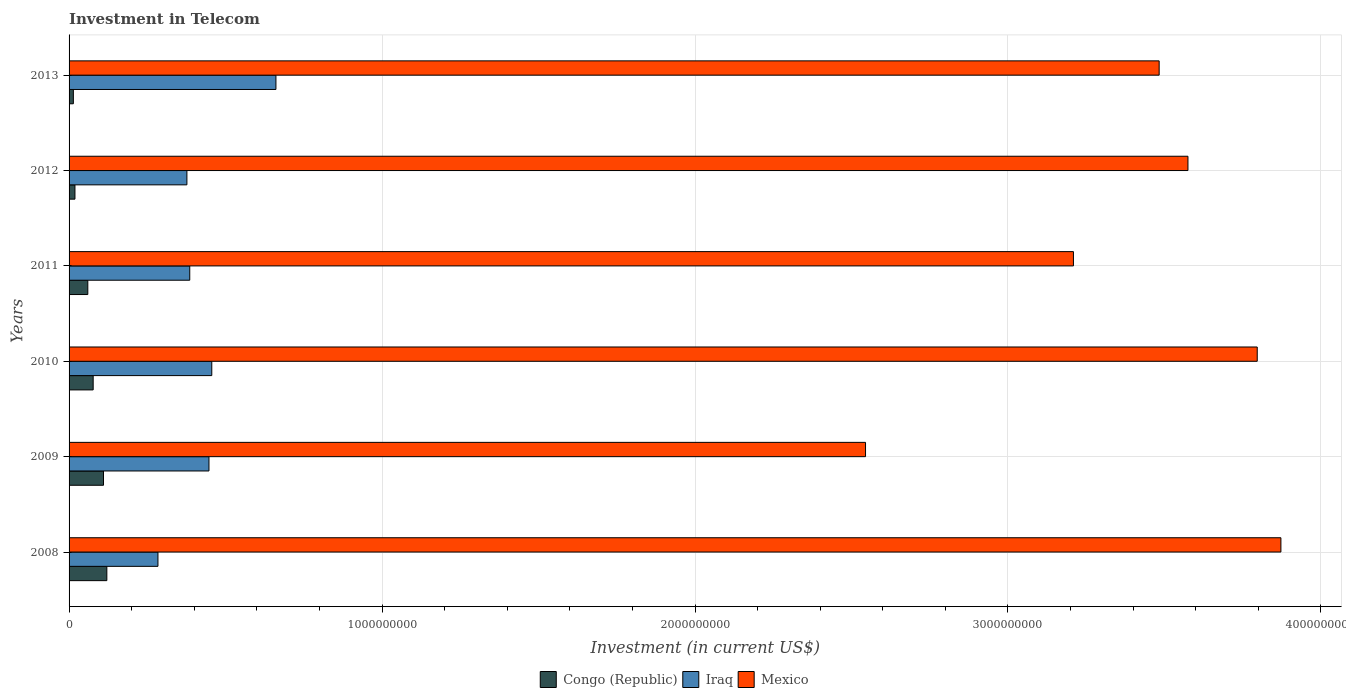How many different coloured bars are there?
Your answer should be compact. 3. How many groups of bars are there?
Make the answer very short. 6. Are the number of bars on each tick of the Y-axis equal?
Offer a terse response. Yes. How many bars are there on the 6th tick from the top?
Make the answer very short. 3. How many bars are there on the 6th tick from the bottom?
Your response must be concise. 3. What is the label of the 5th group of bars from the top?
Provide a succinct answer. 2009. In how many cases, is the number of bars for a given year not equal to the number of legend labels?
Give a very brief answer. 0. What is the amount invested in telecom in Congo (Republic) in 2010?
Provide a short and direct response. 7.70e+07. Across all years, what is the maximum amount invested in telecom in Iraq?
Provide a short and direct response. 6.61e+08. Across all years, what is the minimum amount invested in telecom in Mexico?
Provide a succinct answer. 2.54e+09. In which year was the amount invested in telecom in Mexico maximum?
Provide a succinct answer. 2008. In which year was the amount invested in telecom in Iraq minimum?
Provide a short and direct response. 2008. What is the total amount invested in telecom in Iraq in the graph?
Your answer should be compact. 2.61e+09. What is the difference between the amount invested in telecom in Mexico in 2008 and that in 2010?
Make the answer very short. 7.56e+07. What is the difference between the amount invested in telecom in Mexico in 2011 and the amount invested in telecom in Iraq in 2012?
Make the answer very short. 2.83e+09. What is the average amount invested in telecom in Mexico per year?
Your response must be concise. 3.41e+09. In the year 2012, what is the difference between the amount invested in telecom in Mexico and amount invested in telecom in Congo (Republic)?
Offer a terse response. 3.56e+09. What is the ratio of the amount invested in telecom in Iraq in 2008 to that in 2010?
Provide a short and direct response. 0.62. Is the difference between the amount invested in telecom in Mexico in 2011 and 2013 greater than the difference between the amount invested in telecom in Congo (Republic) in 2011 and 2013?
Provide a short and direct response. No. What is the difference between the highest and the second highest amount invested in telecom in Congo (Republic)?
Provide a succinct answer. 1.07e+07. What is the difference between the highest and the lowest amount invested in telecom in Iraq?
Your answer should be compact. 3.77e+08. In how many years, is the amount invested in telecom in Iraq greater than the average amount invested in telecom in Iraq taken over all years?
Your answer should be very brief. 3. Is the sum of the amount invested in telecom in Iraq in 2011 and 2013 greater than the maximum amount invested in telecom in Mexico across all years?
Offer a very short reply. No. What does the 1st bar from the top in 2010 represents?
Provide a short and direct response. Mexico. What does the 3rd bar from the bottom in 2009 represents?
Keep it short and to the point. Mexico. Is it the case that in every year, the sum of the amount invested in telecom in Mexico and amount invested in telecom in Iraq is greater than the amount invested in telecom in Congo (Republic)?
Make the answer very short. Yes. How many bars are there?
Your answer should be compact. 18. What is the difference between two consecutive major ticks on the X-axis?
Ensure brevity in your answer.  1.00e+09. Does the graph contain any zero values?
Your answer should be compact. No. Where does the legend appear in the graph?
Your response must be concise. Bottom center. How are the legend labels stacked?
Offer a terse response. Horizontal. What is the title of the graph?
Make the answer very short. Investment in Telecom. What is the label or title of the X-axis?
Offer a very short reply. Investment (in current US$). What is the Investment (in current US$) of Congo (Republic) in 2008?
Ensure brevity in your answer.  1.21e+08. What is the Investment (in current US$) of Iraq in 2008?
Provide a succinct answer. 2.84e+08. What is the Investment (in current US$) of Mexico in 2008?
Provide a succinct answer. 3.87e+09. What is the Investment (in current US$) of Congo (Republic) in 2009?
Ensure brevity in your answer.  1.10e+08. What is the Investment (in current US$) of Iraq in 2009?
Your answer should be very brief. 4.47e+08. What is the Investment (in current US$) in Mexico in 2009?
Provide a short and direct response. 2.54e+09. What is the Investment (in current US$) of Congo (Republic) in 2010?
Offer a terse response. 7.70e+07. What is the Investment (in current US$) of Iraq in 2010?
Ensure brevity in your answer.  4.56e+08. What is the Investment (in current US$) in Mexico in 2010?
Provide a succinct answer. 3.80e+09. What is the Investment (in current US$) of Congo (Republic) in 2011?
Your answer should be very brief. 5.99e+07. What is the Investment (in current US$) in Iraq in 2011?
Make the answer very short. 3.86e+08. What is the Investment (in current US$) in Mexico in 2011?
Offer a terse response. 3.21e+09. What is the Investment (in current US$) of Congo (Republic) in 2012?
Keep it short and to the point. 1.88e+07. What is the Investment (in current US$) of Iraq in 2012?
Provide a short and direct response. 3.76e+08. What is the Investment (in current US$) in Mexico in 2012?
Your answer should be very brief. 3.58e+09. What is the Investment (in current US$) of Congo (Republic) in 2013?
Provide a short and direct response. 1.37e+07. What is the Investment (in current US$) in Iraq in 2013?
Offer a terse response. 6.61e+08. What is the Investment (in current US$) in Mexico in 2013?
Give a very brief answer. 3.48e+09. Across all years, what is the maximum Investment (in current US$) of Congo (Republic)?
Ensure brevity in your answer.  1.21e+08. Across all years, what is the maximum Investment (in current US$) in Iraq?
Your answer should be very brief. 6.61e+08. Across all years, what is the maximum Investment (in current US$) of Mexico?
Provide a succinct answer. 3.87e+09. Across all years, what is the minimum Investment (in current US$) of Congo (Republic)?
Provide a succinct answer. 1.37e+07. Across all years, what is the minimum Investment (in current US$) in Iraq?
Your answer should be very brief. 2.84e+08. Across all years, what is the minimum Investment (in current US$) of Mexico?
Ensure brevity in your answer.  2.54e+09. What is the total Investment (in current US$) in Congo (Republic) in the graph?
Keep it short and to the point. 4.00e+08. What is the total Investment (in current US$) in Iraq in the graph?
Your answer should be very brief. 2.61e+09. What is the total Investment (in current US$) of Mexico in the graph?
Your answer should be very brief. 2.05e+1. What is the difference between the Investment (in current US$) in Congo (Republic) in 2008 and that in 2009?
Your response must be concise. 1.07e+07. What is the difference between the Investment (in current US$) in Iraq in 2008 and that in 2009?
Ensure brevity in your answer.  -1.63e+08. What is the difference between the Investment (in current US$) of Mexico in 2008 and that in 2009?
Offer a very short reply. 1.33e+09. What is the difference between the Investment (in current US$) in Congo (Republic) in 2008 and that in 2010?
Offer a very short reply. 4.37e+07. What is the difference between the Investment (in current US$) in Iraq in 2008 and that in 2010?
Offer a terse response. -1.72e+08. What is the difference between the Investment (in current US$) in Mexico in 2008 and that in 2010?
Keep it short and to the point. 7.56e+07. What is the difference between the Investment (in current US$) of Congo (Republic) in 2008 and that in 2011?
Provide a succinct answer. 6.08e+07. What is the difference between the Investment (in current US$) in Iraq in 2008 and that in 2011?
Provide a short and direct response. -1.02e+08. What is the difference between the Investment (in current US$) in Mexico in 2008 and that in 2011?
Ensure brevity in your answer.  6.63e+08. What is the difference between the Investment (in current US$) in Congo (Republic) in 2008 and that in 2012?
Offer a terse response. 1.02e+08. What is the difference between the Investment (in current US$) in Iraq in 2008 and that in 2012?
Keep it short and to the point. -9.25e+07. What is the difference between the Investment (in current US$) in Mexico in 2008 and that in 2012?
Your response must be concise. 2.97e+08. What is the difference between the Investment (in current US$) of Congo (Republic) in 2008 and that in 2013?
Provide a short and direct response. 1.07e+08. What is the difference between the Investment (in current US$) in Iraq in 2008 and that in 2013?
Keep it short and to the point. -3.77e+08. What is the difference between the Investment (in current US$) in Mexico in 2008 and that in 2013?
Offer a terse response. 3.89e+08. What is the difference between the Investment (in current US$) of Congo (Republic) in 2009 and that in 2010?
Ensure brevity in your answer.  3.30e+07. What is the difference between the Investment (in current US$) in Iraq in 2009 and that in 2010?
Offer a terse response. -9.00e+06. What is the difference between the Investment (in current US$) of Mexico in 2009 and that in 2010?
Ensure brevity in your answer.  -1.25e+09. What is the difference between the Investment (in current US$) in Congo (Republic) in 2009 and that in 2011?
Your answer should be compact. 5.01e+07. What is the difference between the Investment (in current US$) in Iraq in 2009 and that in 2011?
Offer a very short reply. 6.14e+07. What is the difference between the Investment (in current US$) in Mexico in 2009 and that in 2011?
Your response must be concise. -6.64e+08. What is the difference between the Investment (in current US$) in Congo (Republic) in 2009 and that in 2012?
Make the answer very short. 9.12e+07. What is the difference between the Investment (in current US$) of Iraq in 2009 and that in 2012?
Your response must be concise. 7.05e+07. What is the difference between the Investment (in current US$) of Mexico in 2009 and that in 2012?
Give a very brief answer. -1.03e+09. What is the difference between the Investment (in current US$) in Congo (Republic) in 2009 and that in 2013?
Give a very brief answer. 9.63e+07. What is the difference between the Investment (in current US$) in Iraq in 2009 and that in 2013?
Give a very brief answer. -2.14e+08. What is the difference between the Investment (in current US$) of Mexico in 2009 and that in 2013?
Your answer should be very brief. -9.38e+08. What is the difference between the Investment (in current US$) in Congo (Republic) in 2010 and that in 2011?
Keep it short and to the point. 1.71e+07. What is the difference between the Investment (in current US$) in Iraq in 2010 and that in 2011?
Your answer should be very brief. 7.04e+07. What is the difference between the Investment (in current US$) of Mexico in 2010 and that in 2011?
Make the answer very short. 5.87e+08. What is the difference between the Investment (in current US$) of Congo (Republic) in 2010 and that in 2012?
Offer a terse response. 5.82e+07. What is the difference between the Investment (in current US$) of Iraq in 2010 and that in 2012?
Your answer should be very brief. 7.95e+07. What is the difference between the Investment (in current US$) of Mexico in 2010 and that in 2012?
Ensure brevity in your answer.  2.21e+08. What is the difference between the Investment (in current US$) of Congo (Republic) in 2010 and that in 2013?
Offer a very short reply. 6.33e+07. What is the difference between the Investment (in current US$) of Iraq in 2010 and that in 2013?
Ensure brevity in your answer.  -2.05e+08. What is the difference between the Investment (in current US$) of Mexico in 2010 and that in 2013?
Give a very brief answer. 3.13e+08. What is the difference between the Investment (in current US$) in Congo (Republic) in 2011 and that in 2012?
Give a very brief answer. 4.11e+07. What is the difference between the Investment (in current US$) of Iraq in 2011 and that in 2012?
Keep it short and to the point. 9.10e+06. What is the difference between the Investment (in current US$) of Mexico in 2011 and that in 2012?
Your answer should be very brief. -3.66e+08. What is the difference between the Investment (in current US$) in Congo (Republic) in 2011 and that in 2013?
Make the answer very short. 4.62e+07. What is the difference between the Investment (in current US$) in Iraq in 2011 and that in 2013?
Your answer should be compact. -2.75e+08. What is the difference between the Investment (in current US$) of Mexico in 2011 and that in 2013?
Your answer should be very brief. -2.74e+08. What is the difference between the Investment (in current US$) in Congo (Republic) in 2012 and that in 2013?
Ensure brevity in your answer.  5.10e+06. What is the difference between the Investment (in current US$) of Iraq in 2012 and that in 2013?
Keep it short and to the point. -2.84e+08. What is the difference between the Investment (in current US$) of Mexico in 2012 and that in 2013?
Your answer should be very brief. 9.20e+07. What is the difference between the Investment (in current US$) in Congo (Republic) in 2008 and the Investment (in current US$) in Iraq in 2009?
Your answer should be compact. -3.26e+08. What is the difference between the Investment (in current US$) in Congo (Republic) in 2008 and the Investment (in current US$) in Mexico in 2009?
Provide a short and direct response. -2.42e+09. What is the difference between the Investment (in current US$) in Iraq in 2008 and the Investment (in current US$) in Mexico in 2009?
Your answer should be very brief. -2.26e+09. What is the difference between the Investment (in current US$) of Congo (Republic) in 2008 and the Investment (in current US$) of Iraq in 2010?
Your answer should be very brief. -3.35e+08. What is the difference between the Investment (in current US$) in Congo (Republic) in 2008 and the Investment (in current US$) in Mexico in 2010?
Offer a terse response. -3.68e+09. What is the difference between the Investment (in current US$) of Iraq in 2008 and the Investment (in current US$) of Mexico in 2010?
Your answer should be compact. -3.51e+09. What is the difference between the Investment (in current US$) of Congo (Republic) in 2008 and the Investment (in current US$) of Iraq in 2011?
Keep it short and to the point. -2.65e+08. What is the difference between the Investment (in current US$) in Congo (Republic) in 2008 and the Investment (in current US$) in Mexico in 2011?
Provide a short and direct response. -3.09e+09. What is the difference between the Investment (in current US$) in Iraq in 2008 and the Investment (in current US$) in Mexico in 2011?
Your response must be concise. -2.93e+09. What is the difference between the Investment (in current US$) in Congo (Republic) in 2008 and the Investment (in current US$) in Iraq in 2012?
Provide a succinct answer. -2.56e+08. What is the difference between the Investment (in current US$) in Congo (Republic) in 2008 and the Investment (in current US$) in Mexico in 2012?
Ensure brevity in your answer.  -3.45e+09. What is the difference between the Investment (in current US$) of Iraq in 2008 and the Investment (in current US$) of Mexico in 2012?
Your answer should be compact. -3.29e+09. What is the difference between the Investment (in current US$) in Congo (Republic) in 2008 and the Investment (in current US$) in Iraq in 2013?
Provide a succinct answer. -5.40e+08. What is the difference between the Investment (in current US$) in Congo (Republic) in 2008 and the Investment (in current US$) in Mexico in 2013?
Your answer should be very brief. -3.36e+09. What is the difference between the Investment (in current US$) in Iraq in 2008 and the Investment (in current US$) in Mexico in 2013?
Offer a terse response. -3.20e+09. What is the difference between the Investment (in current US$) in Congo (Republic) in 2009 and the Investment (in current US$) in Iraq in 2010?
Give a very brief answer. -3.46e+08. What is the difference between the Investment (in current US$) in Congo (Republic) in 2009 and the Investment (in current US$) in Mexico in 2010?
Offer a terse response. -3.69e+09. What is the difference between the Investment (in current US$) in Iraq in 2009 and the Investment (in current US$) in Mexico in 2010?
Your answer should be compact. -3.35e+09. What is the difference between the Investment (in current US$) of Congo (Republic) in 2009 and the Investment (in current US$) of Iraq in 2011?
Your answer should be very brief. -2.76e+08. What is the difference between the Investment (in current US$) of Congo (Republic) in 2009 and the Investment (in current US$) of Mexico in 2011?
Your answer should be compact. -3.10e+09. What is the difference between the Investment (in current US$) of Iraq in 2009 and the Investment (in current US$) of Mexico in 2011?
Give a very brief answer. -2.76e+09. What is the difference between the Investment (in current US$) in Congo (Republic) in 2009 and the Investment (in current US$) in Iraq in 2012?
Offer a terse response. -2.66e+08. What is the difference between the Investment (in current US$) of Congo (Republic) in 2009 and the Investment (in current US$) of Mexico in 2012?
Your answer should be compact. -3.47e+09. What is the difference between the Investment (in current US$) in Iraq in 2009 and the Investment (in current US$) in Mexico in 2012?
Offer a very short reply. -3.13e+09. What is the difference between the Investment (in current US$) in Congo (Republic) in 2009 and the Investment (in current US$) in Iraq in 2013?
Your answer should be compact. -5.51e+08. What is the difference between the Investment (in current US$) in Congo (Republic) in 2009 and the Investment (in current US$) in Mexico in 2013?
Ensure brevity in your answer.  -3.37e+09. What is the difference between the Investment (in current US$) in Iraq in 2009 and the Investment (in current US$) in Mexico in 2013?
Your answer should be compact. -3.04e+09. What is the difference between the Investment (in current US$) in Congo (Republic) in 2010 and the Investment (in current US$) in Iraq in 2011?
Offer a terse response. -3.09e+08. What is the difference between the Investment (in current US$) of Congo (Republic) in 2010 and the Investment (in current US$) of Mexico in 2011?
Your answer should be very brief. -3.13e+09. What is the difference between the Investment (in current US$) in Iraq in 2010 and the Investment (in current US$) in Mexico in 2011?
Provide a succinct answer. -2.75e+09. What is the difference between the Investment (in current US$) in Congo (Republic) in 2010 and the Investment (in current US$) in Iraq in 2012?
Give a very brief answer. -3.00e+08. What is the difference between the Investment (in current US$) of Congo (Republic) in 2010 and the Investment (in current US$) of Mexico in 2012?
Keep it short and to the point. -3.50e+09. What is the difference between the Investment (in current US$) of Iraq in 2010 and the Investment (in current US$) of Mexico in 2012?
Give a very brief answer. -3.12e+09. What is the difference between the Investment (in current US$) in Congo (Republic) in 2010 and the Investment (in current US$) in Iraq in 2013?
Offer a very short reply. -5.84e+08. What is the difference between the Investment (in current US$) in Congo (Republic) in 2010 and the Investment (in current US$) in Mexico in 2013?
Offer a terse response. -3.41e+09. What is the difference between the Investment (in current US$) of Iraq in 2010 and the Investment (in current US$) of Mexico in 2013?
Keep it short and to the point. -3.03e+09. What is the difference between the Investment (in current US$) in Congo (Republic) in 2011 and the Investment (in current US$) in Iraq in 2012?
Your response must be concise. -3.17e+08. What is the difference between the Investment (in current US$) of Congo (Republic) in 2011 and the Investment (in current US$) of Mexico in 2012?
Your answer should be very brief. -3.52e+09. What is the difference between the Investment (in current US$) of Iraq in 2011 and the Investment (in current US$) of Mexico in 2012?
Your response must be concise. -3.19e+09. What is the difference between the Investment (in current US$) of Congo (Republic) in 2011 and the Investment (in current US$) of Iraq in 2013?
Your answer should be compact. -6.01e+08. What is the difference between the Investment (in current US$) in Congo (Republic) in 2011 and the Investment (in current US$) in Mexico in 2013?
Offer a very short reply. -3.42e+09. What is the difference between the Investment (in current US$) of Iraq in 2011 and the Investment (in current US$) of Mexico in 2013?
Give a very brief answer. -3.10e+09. What is the difference between the Investment (in current US$) in Congo (Republic) in 2012 and the Investment (in current US$) in Iraq in 2013?
Keep it short and to the point. -6.42e+08. What is the difference between the Investment (in current US$) in Congo (Republic) in 2012 and the Investment (in current US$) in Mexico in 2013?
Your answer should be very brief. -3.46e+09. What is the difference between the Investment (in current US$) in Iraq in 2012 and the Investment (in current US$) in Mexico in 2013?
Make the answer very short. -3.11e+09. What is the average Investment (in current US$) in Congo (Republic) per year?
Give a very brief answer. 6.67e+07. What is the average Investment (in current US$) in Iraq per year?
Ensure brevity in your answer.  4.35e+08. What is the average Investment (in current US$) of Mexico per year?
Offer a very short reply. 3.41e+09. In the year 2008, what is the difference between the Investment (in current US$) of Congo (Republic) and Investment (in current US$) of Iraq?
Make the answer very short. -1.63e+08. In the year 2008, what is the difference between the Investment (in current US$) of Congo (Republic) and Investment (in current US$) of Mexico?
Keep it short and to the point. -3.75e+09. In the year 2008, what is the difference between the Investment (in current US$) of Iraq and Investment (in current US$) of Mexico?
Ensure brevity in your answer.  -3.59e+09. In the year 2009, what is the difference between the Investment (in current US$) of Congo (Republic) and Investment (in current US$) of Iraq?
Give a very brief answer. -3.37e+08. In the year 2009, what is the difference between the Investment (in current US$) of Congo (Republic) and Investment (in current US$) of Mexico?
Your response must be concise. -2.43e+09. In the year 2009, what is the difference between the Investment (in current US$) of Iraq and Investment (in current US$) of Mexico?
Offer a terse response. -2.10e+09. In the year 2010, what is the difference between the Investment (in current US$) in Congo (Republic) and Investment (in current US$) in Iraq?
Your response must be concise. -3.79e+08. In the year 2010, what is the difference between the Investment (in current US$) of Congo (Republic) and Investment (in current US$) of Mexico?
Your response must be concise. -3.72e+09. In the year 2010, what is the difference between the Investment (in current US$) of Iraq and Investment (in current US$) of Mexico?
Your response must be concise. -3.34e+09. In the year 2011, what is the difference between the Investment (in current US$) in Congo (Republic) and Investment (in current US$) in Iraq?
Provide a short and direct response. -3.26e+08. In the year 2011, what is the difference between the Investment (in current US$) of Congo (Republic) and Investment (in current US$) of Mexico?
Your response must be concise. -3.15e+09. In the year 2011, what is the difference between the Investment (in current US$) in Iraq and Investment (in current US$) in Mexico?
Your answer should be very brief. -2.82e+09. In the year 2012, what is the difference between the Investment (in current US$) of Congo (Republic) and Investment (in current US$) of Iraq?
Offer a very short reply. -3.58e+08. In the year 2012, what is the difference between the Investment (in current US$) of Congo (Republic) and Investment (in current US$) of Mexico?
Offer a terse response. -3.56e+09. In the year 2012, what is the difference between the Investment (in current US$) in Iraq and Investment (in current US$) in Mexico?
Offer a very short reply. -3.20e+09. In the year 2013, what is the difference between the Investment (in current US$) in Congo (Republic) and Investment (in current US$) in Iraq?
Offer a very short reply. -6.47e+08. In the year 2013, what is the difference between the Investment (in current US$) of Congo (Republic) and Investment (in current US$) of Mexico?
Your answer should be very brief. -3.47e+09. In the year 2013, what is the difference between the Investment (in current US$) in Iraq and Investment (in current US$) in Mexico?
Provide a short and direct response. -2.82e+09. What is the ratio of the Investment (in current US$) of Congo (Republic) in 2008 to that in 2009?
Give a very brief answer. 1.1. What is the ratio of the Investment (in current US$) in Iraq in 2008 to that in 2009?
Ensure brevity in your answer.  0.64. What is the ratio of the Investment (in current US$) of Mexico in 2008 to that in 2009?
Offer a terse response. 1.52. What is the ratio of the Investment (in current US$) in Congo (Republic) in 2008 to that in 2010?
Ensure brevity in your answer.  1.57. What is the ratio of the Investment (in current US$) in Iraq in 2008 to that in 2010?
Your answer should be compact. 0.62. What is the ratio of the Investment (in current US$) of Mexico in 2008 to that in 2010?
Give a very brief answer. 1.02. What is the ratio of the Investment (in current US$) in Congo (Republic) in 2008 to that in 2011?
Provide a short and direct response. 2.02. What is the ratio of the Investment (in current US$) of Iraq in 2008 to that in 2011?
Your answer should be very brief. 0.74. What is the ratio of the Investment (in current US$) of Mexico in 2008 to that in 2011?
Your response must be concise. 1.21. What is the ratio of the Investment (in current US$) of Congo (Republic) in 2008 to that in 2012?
Provide a succinct answer. 6.42. What is the ratio of the Investment (in current US$) of Iraq in 2008 to that in 2012?
Provide a succinct answer. 0.75. What is the ratio of the Investment (in current US$) of Mexico in 2008 to that in 2012?
Ensure brevity in your answer.  1.08. What is the ratio of the Investment (in current US$) in Congo (Republic) in 2008 to that in 2013?
Keep it short and to the point. 8.81. What is the ratio of the Investment (in current US$) in Iraq in 2008 to that in 2013?
Offer a very short reply. 0.43. What is the ratio of the Investment (in current US$) of Mexico in 2008 to that in 2013?
Give a very brief answer. 1.11. What is the ratio of the Investment (in current US$) in Congo (Republic) in 2009 to that in 2010?
Ensure brevity in your answer.  1.43. What is the ratio of the Investment (in current US$) in Iraq in 2009 to that in 2010?
Your response must be concise. 0.98. What is the ratio of the Investment (in current US$) of Mexico in 2009 to that in 2010?
Offer a very short reply. 0.67. What is the ratio of the Investment (in current US$) of Congo (Republic) in 2009 to that in 2011?
Offer a terse response. 1.84. What is the ratio of the Investment (in current US$) of Iraq in 2009 to that in 2011?
Give a very brief answer. 1.16. What is the ratio of the Investment (in current US$) in Mexico in 2009 to that in 2011?
Give a very brief answer. 0.79. What is the ratio of the Investment (in current US$) of Congo (Republic) in 2009 to that in 2012?
Offer a very short reply. 5.85. What is the ratio of the Investment (in current US$) of Iraq in 2009 to that in 2012?
Offer a terse response. 1.19. What is the ratio of the Investment (in current US$) of Mexico in 2009 to that in 2012?
Make the answer very short. 0.71. What is the ratio of the Investment (in current US$) of Congo (Republic) in 2009 to that in 2013?
Make the answer very short. 8.03. What is the ratio of the Investment (in current US$) of Iraq in 2009 to that in 2013?
Your answer should be compact. 0.68. What is the ratio of the Investment (in current US$) of Mexico in 2009 to that in 2013?
Your answer should be very brief. 0.73. What is the ratio of the Investment (in current US$) in Congo (Republic) in 2010 to that in 2011?
Offer a very short reply. 1.29. What is the ratio of the Investment (in current US$) in Iraq in 2010 to that in 2011?
Keep it short and to the point. 1.18. What is the ratio of the Investment (in current US$) in Mexico in 2010 to that in 2011?
Ensure brevity in your answer.  1.18. What is the ratio of the Investment (in current US$) in Congo (Republic) in 2010 to that in 2012?
Give a very brief answer. 4.1. What is the ratio of the Investment (in current US$) of Iraq in 2010 to that in 2012?
Your answer should be very brief. 1.21. What is the ratio of the Investment (in current US$) of Mexico in 2010 to that in 2012?
Your response must be concise. 1.06. What is the ratio of the Investment (in current US$) of Congo (Republic) in 2010 to that in 2013?
Your response must be concise. 5.62. What is the ratio of the Investment (in current US$) in Iraq in 2010 to that in 2013?
Provide a short and direct response. 0.69. What is the ratio of the Investment (in current US$) of Mexico in 2010 to that in 2013?
Your answer should be very brief. 1.09. What is the ratio of the Investment (in current US$) of Congo (Republic) in 2011 to that in 2012?
Offer a terse response. 3.19. What is the ratio of the Investment (in current US$) of Iraq in 2011 to that in 2012?
Provide a succinct answer. 1.02. What is the ratio of the Investment (in current US$) of Mexico in 2011 to that in 2012?
Give a very brief answer. 0.9. What is the ratio of the Investment (in current US$) in Congo (Republic) in 2011 to that in 2013?
Your response must be concise. 4.37. What is the ratio of the Investment (in current US$) in Iraq in 2011 to that in 2013?
Your answer should be very brief. 0.58. What is the ratio of the Investment (in current US$) of Mexico in 2011 to that in 2013?
Make the answer very short. 0.92. What is the ratio of the Investment (in current US$) of Congo (Republic) in 2012 to that in 2013?
Provide a short and direct response. 1.37. What is the ratio of the Investment (in current US$) in Iraq in 2012 to that in 2013?
Offer a very short reply. 0.57. What is the ratio of the Investment (in current US$) in Mexico in 2012 to that in 2013?
Provide a succinct answer. 1.03. What is the difference between the highest and the second highest Investment (in current US$) in Congo (Republic)?
Provide a succinct answer. 1.07e+07. What is the difference between the highest and the second highest Investment (in current US$) of Iraq?
Provide a short and direct response. 2.05e+08. What is the difference between the highest and the second highest Investment (in current US$) in Mexico?
Keep it short and to the point. 7.56e+07. What is the difference between the highest and the lowest Investment (in current US$) in Congo (Republic)?
Provide a succinct answer. 1.07e+08. What is the difference between the highest and the lowest Investment (in current US$) of Iraq?
Give a very brief answer. 3.77e+08. What is the difference between the highest and the lowest Investment (in current US$) in Mexico?
Keep it short and to the point. 1.33e+09. 